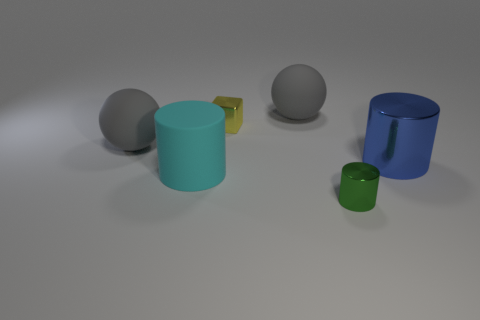What material is the gray ball that is on the right side of the small metallic object that is behind the tiny metal thing to the right of the yellow metallic block made of?
Ensure brevity in your answer.  Rubber. There is a green cylinder; is it the same size as the thing to the left of the large cyan cylinder?
Provide a short and direct response. No. There is a small green object that is the same shape as the cyan object; what material is it?
Offer a terse response. Metal. What size is the shiny cylinder that is left of the metal cylinder that is right of the shiny cylinder to the left of the large blue cylinder?
Provide a succinct answer. Small. Do the cyan matte cylinder and the green cylinder have the same size?
Provide a succinct answer. No. The large cylinder on the left side of the blue cylinder to the right of the green cylinder is made of what material?
Offer a very short reply. Rubber. There is a matte thing on the right side of the yellow metallic thing; is it the same shape as the small yellow thing on the right side of the big cyan rubber object?
Make the answer very short. No. Are there an equal number of large cyan cylinders that are behind the large blue object and yellow metallic blocks?
Ensure brevity in your answer.  No. Are there any matte cylinders to the left of the cylinder that is to the left of the green cylinder?
Your answer should be compact. No. Is there any other thing of the same color as the tiny shiny cylinder?
Provide a short and direct response. No. 